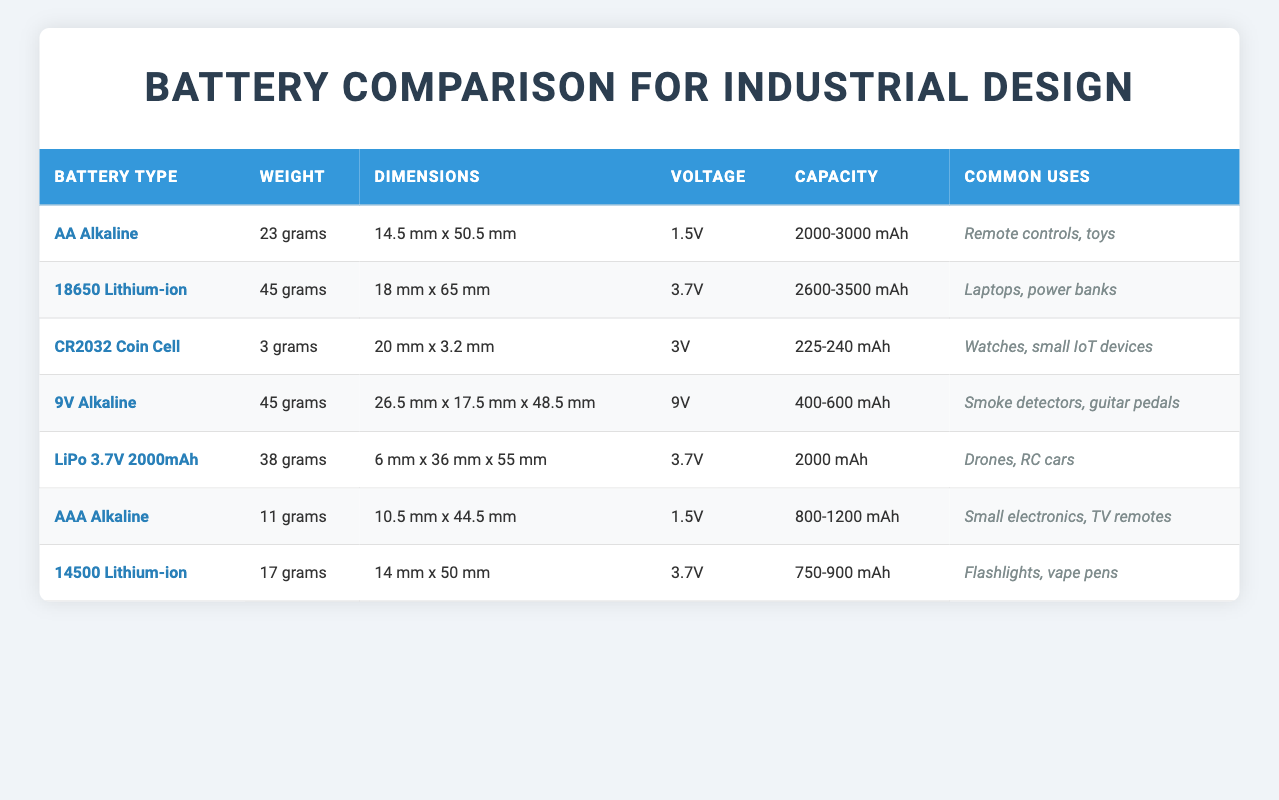What is the weight of the CR2032 Coin Cell? The table lists the weight of the CR2032 Coin Cell directly in the corresponding row under the "Weight" column, which states that it is 3 grams.
Answer: 3 grams Which battery type has the highest capacity? To find the battery type with the highest capacity, we can compare the values in the "Capacity" column. The 18650 Lithium-ion has a capacity range of 2600-3500 mAh, which is the highest among all battery types in the table.
Answer: 18650 Lithium-ion How many grams heavier is the AA Alkaline battery compared to the AAA Alkaline battery? The weight of the AA Alkaline battery is 23 grams, and the weight of the AAA Alkaline battery is 11 grams. To find the difference, we subtract the weight of the AAA from the weight of the AA: 23 grams - 11 grams = 12 grams.
Answer: 12 grams Do both lithium-ion batteries have the same voltage? The table shows that the 18650 Lithium-ion has a voltage of 3.7V, while the 14500 Lithium-ion also has a voltage of 3.7V. Since both have the same voltage, the answer is yes.
Answer: Yes What is the average weight of all alkaline batteries listed in the table? We first identify all alkaline batteries: AA (23g), AAA (11g), and 9V (45g). We sum their weights: 23 + 11 + 45 = 79 grams. There are 3 alkaline batteries, so we divide by 3 to find the average: 79 grams / 3 = 26.33 grams.
Answer: 26.33 grams Which battery type is the most lightweight? By examining the "Weight" column, we can see that the CR2032 Coin Cell has the lightest weight at 3 grams, which is lower than all other battery types.
Answer: CR2032 Coin Cell How many batteries commonly used in remote controls and toys have a capacity greater than 1000 mAh? The AA Alkaline battery (capacity 2000-3000 mAh) meets the criteria, as well as the 18650 Lithium-ion (capacity 2600-3500 mAh). Hence there are 2 batteries.
Answer: 2 batteries Is the 9V Alkaline battery commonly used in smoke detectors? The table indicates that the 9V Alkaline is stated under "Common Uses" as being used in smoke detectors, confirming that this fact is true.
Answer: Yes What is the total capacity of all batteries excluding the CR2032 Coin Cell? We sum the capacities of other battery types: AA Alkaline (2000-3000 mAh), 18650 Lithium-ion (2600-3500 mAh), 9V Alkaline (400-600 mAh), LiPo 3.7V 2000mAh (2000 mAh), AAA Alkaline (800-1200 mAh), and 14500 Lithium-ion (750-900 mAh). We take the lowest possible values for total capacity: 2000 + 2600 + 400 + 2000 + 800 + 750 = 10450. The highest possible value would be: 3000 + 3500 + 600 + 2000 + 1200 + 900 = 12800. Thus, the total capacity range is 10450-12800 mAh when excluding the CR2032 Coin Cell.
Answer: 10450-12800 mAh 